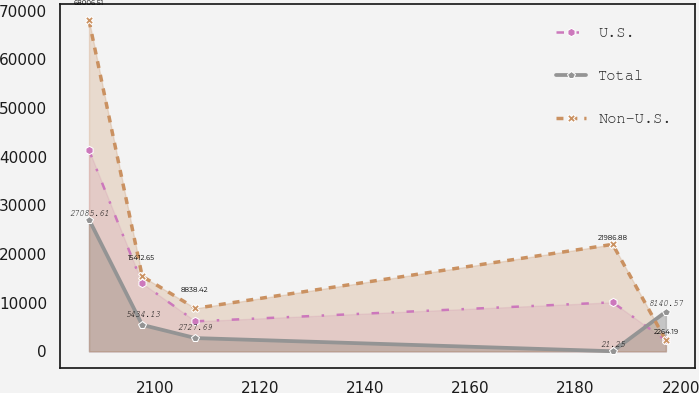Convert chart to OTSL. <chart><loc_0><loc_0><loc_500><loc_500><line_chart><ecel><fcel>U.S.<fcel>Total<fcel>Non-U.S.<nl><fcel>2087.45<fcel>41322.6<fcel>27085.6<fcel>68006.5<nl><fcel>2097.57<fcel>13981<fcel>5434.13<fcel>15412.6<nl><fcel>2107.69<fcel>6169.07<fcel>2727.69<fcel>8838.42<nl><fcel>2187.06<fcel>10075<fcel>21.25<fcel>21986.9<nl><fcel>2197.18<fcel>2263.13<fcel>8140.57<fcel>2264.19<nl></chart> 